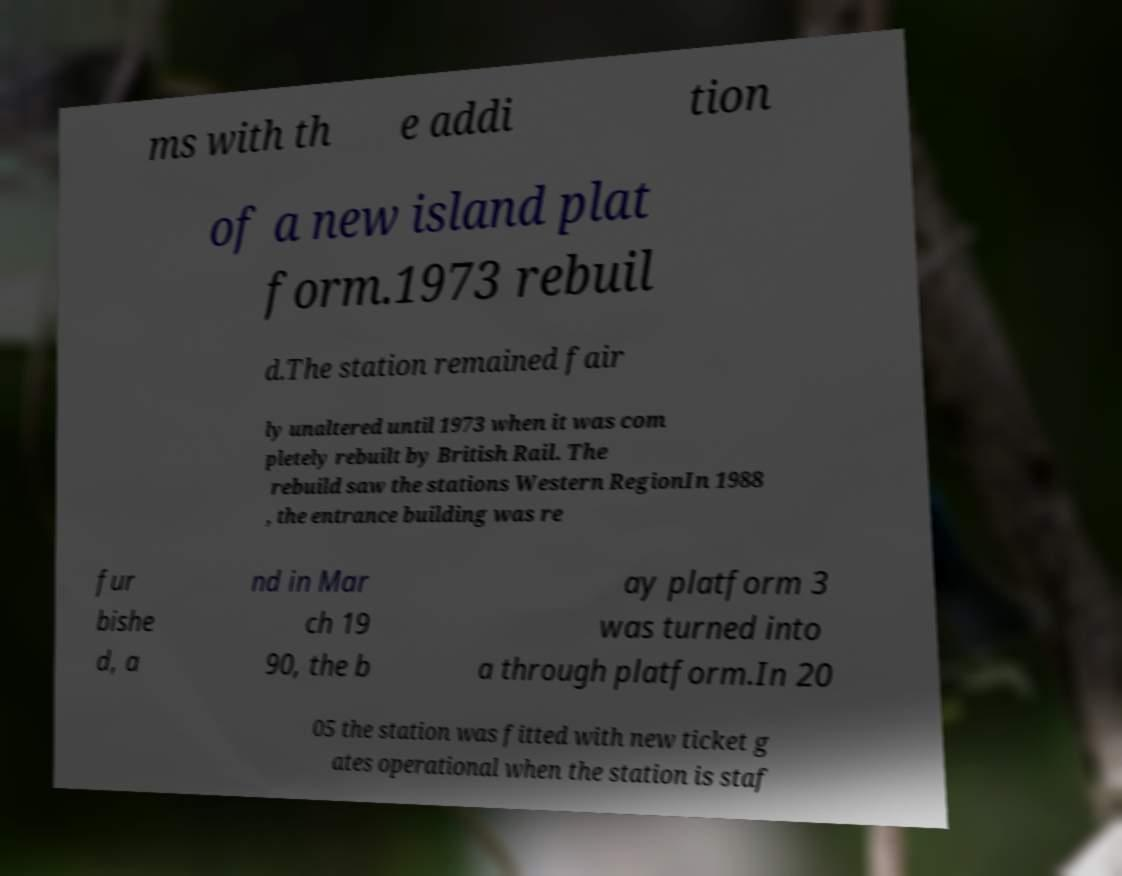What messages or text are displayed in this image? I need them in a readable, typed format. ms with th e addi tion of a new island plat form.1973 rebuil d.The station remained fair ly unaltered until 1973 when it was com pletely rebuilt by British Rail. The rebuild saw the stations Western RegionIn 1988 , the entrance building was re fur bishe d, a nd in Mar ch 19 90, the b ay platform 3 was turned into a through platform.In 20 05 the station was fitted with new ticket g ates operational when the station is staf 